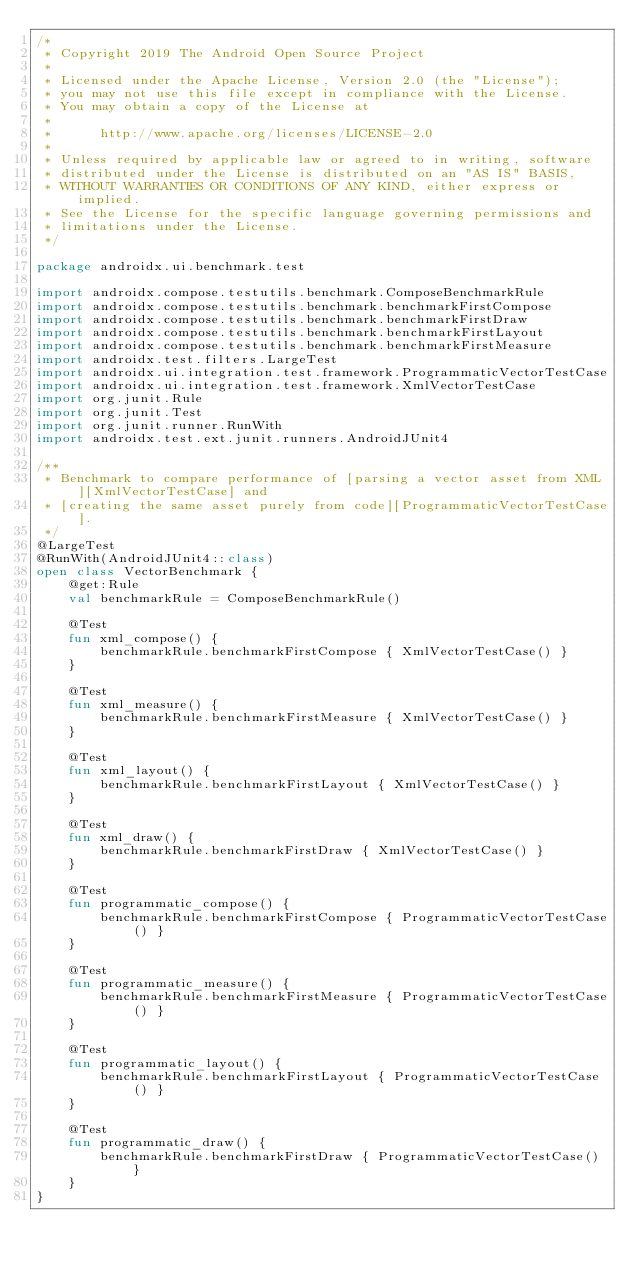Convert code to text. <code><loc_0><loc_0><loc_500><loc_500><_Kotlin_>/*
 * Copyright 2019 The Android Open Source Project
 *
 * Licensed under the Apache License, Version 2.0 (the "License");
 * you may not use this file except in compliance with the License.
 * You may obtain a copy of the License at
 *
 *      http://www.apache.org/licenses/LICENSE-2.0
 *
 * Unless required by applicable law or agreed to in writing, software
 * distributed under the License is distributed on an "AS IS" BASIS,
 * WITHOUT WARRANTIES OR CONDITIONS OF ANY KIND, either express or implied.
 * See the License for the specific language governing permissions and
 * limitations under the License.
 */

package androidx.ui.benchmark.test

import androidx.compose.testutils.benchmark.ComposeBenchmarkRule
import androidx.compose.testutils.benchmark.benchmarkFirstCompose
import androidx.compose.testutils.benchmark.benchmarkFirstDraw
import androidx.compose.testutils.benchmark.benchmarkFirstLayout
import androidx.compose.testutils.benchmark.benchmarkFirstMeasure
import androidx.test.filters.LargeTest
import androidx.ui.integration.test.framework.ProgrammaticVectorTestCase
import androidx.ui.integration.test.framework.XmlVectorTestCase
import org.junit.Rule
import org.junit.Test
import org.junit.runner.RunWith
import androidx.test.ext.junit.runners.AndroidJUnit4

/**
 * Benchmark to compare performance of [parsing a vector asset from XML][XmlVectorTestCase] and
 * [creating the same asset purely from code][ProgrammaticVectorTestCase].
 */
@LargeTest
@RunWith(AndroidJUnit4::class)
open class VectorBenchmark {
    @get:Rule
    val benchmarkRule = ComposeBenchmarkRule()

    @Test
    fun xml_compose() {
        benchmarkRule.benchmarkFirstCompose { XmlVectorTestCase() }
    }

    @Test
    fun xml_measure() {
        benchmarkRule.benchmarkFirstMeasure { XmlVectorTestCase() }
    }

    @Test
    fun xml_layout() {
        benchmarkRule.benchmarkFirstLayout { XmlVectorTestCase() }
    }

    @Test
    fun xml_draw() {
        benchmarkRule.benchmarkFirstDraw { XmlVectorTestCase() }
    }

    @Test
    fun programmatic_compose() {
        benchmarkRule.benchmarkFirstCompose { ProgrammaticVectorTestCase() }
    }

    @Test
    fun programmatic_measure() {
        benchmarkRule.benchmarkFirstMeasure { ProgrammaticVectorTestCase() }
    }

    @Test
    fun programmatic_layout() {
        benchmarkRule.benchmarkFirstLayout { ProgrammaticVectorTestCase() }
    }

    @Test
    fun programmatic_draw() {
        benchmarkRule.benchmarkFirstDraw { ProgrammaticVectorTestCase() }
    }
}
</code> 